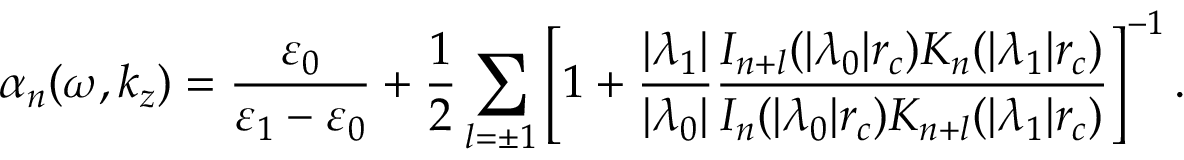<formula> <loc_0><loc_0><loc_500><loc_500>\alpha _ { n } ( \omega , k _ { z } ) = \frac { \varepsilon _ { 0 } } { \varepsilon _ { 1 } - \varepsilon _ { 0 } } + \frac { 1 } { 2 } \sum _ { l = \pm 1 } \left [ 1 + \frac { | \lambda _ { 1 } | } { | \lambda _ { 0 } | } \frac { I _ { n + l } ( | \lambda _ { 0 } | r _ { c } ) K _ { n } ( | \lambda _ { 1 } | r _ { c } ) } { I _ { n } ( | \lambda _ { 0 } | r _ { c } ) K _ { n + l } ( | \lambda _ { 1 } | r _ { c } ) } \right ] ^ { - 1 } .</formula> 